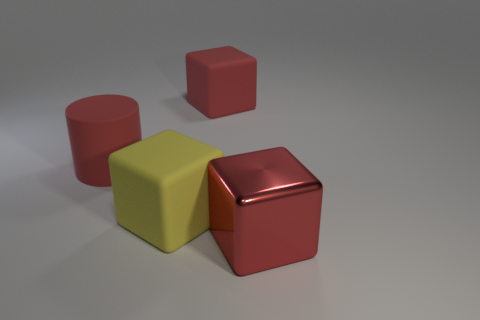Is the number of yellow objects behind the large red matte cube the same as the number of blocks?
Your answer should be compact. No. How many things have the same material as the large red cylinder?
Your answer should be compact. 2. Do the yellow object and the red metallic thing have the same shape?
Keep it short and to the point. Yes. Is there a big metal thing right of the red cube that is on the left side of the red thing that is in front of the big red rubber cylinder?
Keep it short and to the point. Yes. What number of metal objects have the same color as the big matte cylinder?
Offer a terse response. 1. There is a yellow object that is the same size as the red rubber cylinder; what shape is it?
Offer a terse response. Cube. There is a large yellow rubber thing; are there any yellow rubber things on the left side of it?
Provide a short and direct response. No. Do the rubber cylinder and the metallic thing have the same size?
Ensure brevity in your answer.  Yes. There is a red matte thing behind the large rubber cylinder; what is its shape?
Ensure brevity in your answer.  Cube. Is there another red cylinder that has the same size as the cylinder?
Ensure brevity in your answer.  No. 